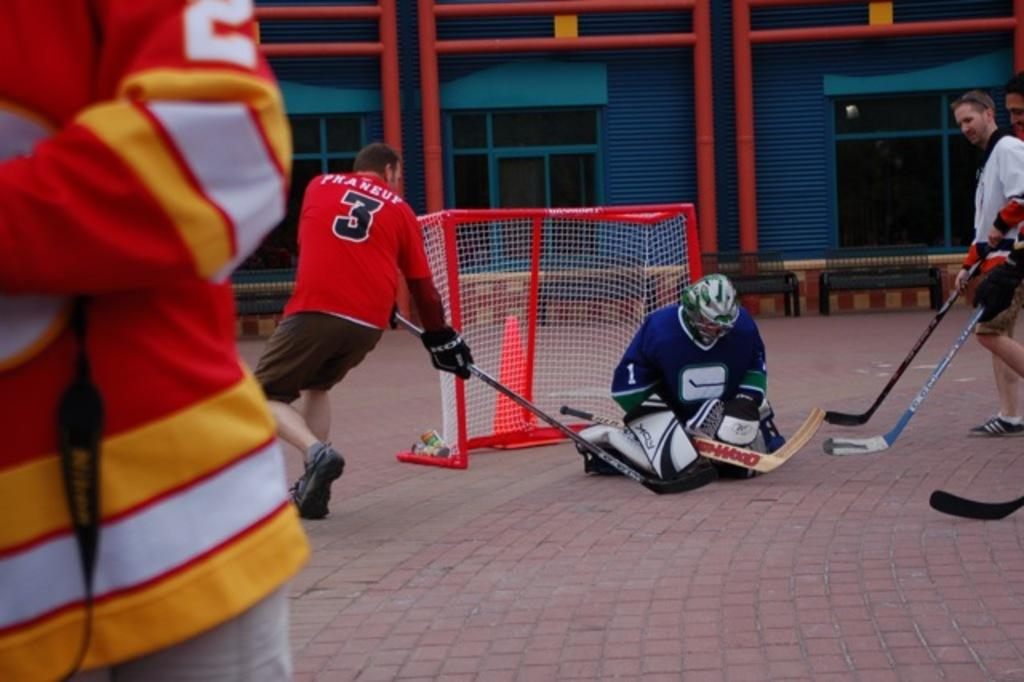Provide a one-sentence caption for the provided image. One man in a group of hockey players has a number 3 on his orange colored shirt. 